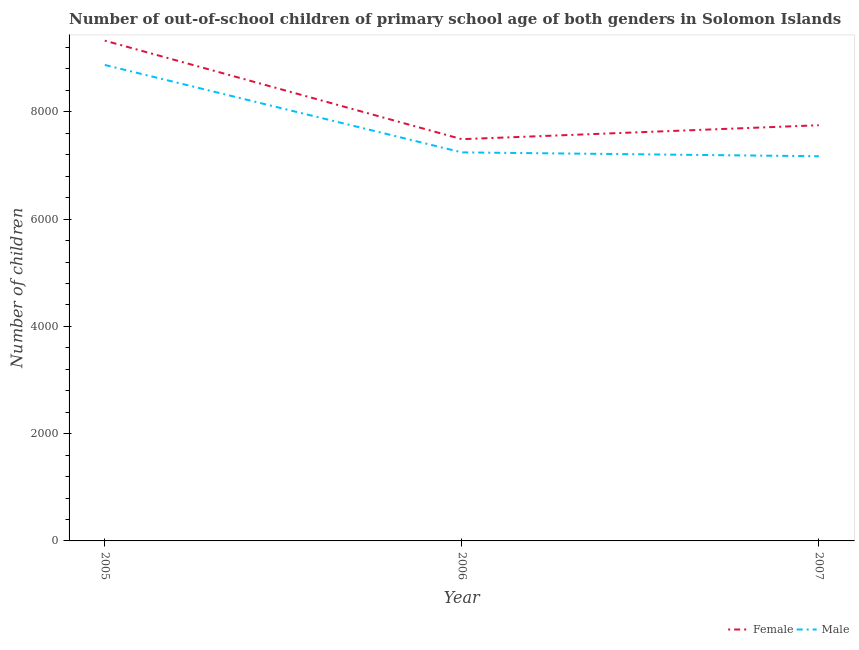Does the line corresponding to number of male out-of-school students intersect with the line corresponding to number of female out-of-school students?
Make the answer very short. No. What is the number of male out-of-school students in 2005?
Make the answer very short. 8874. Across all years, what is the maximum number of male out-of-school students?
Your answer should be very brief. 8874. Across all years, what is the minimum number of female out-of-school students?
Ensure brevity in your answer.  7490. What is the total number of male out-of-school students in the graph?
Provide a succinct answer. 2.33e+04. What is the difference between the number of male out-of-school students in 2006 and that in 2007?
Your answer should be compact. 72. What is the difference between the number of male out-of-school students in 2006 and the number of female out-of-school students in 2005?
Offer a very short reply. -2083. What is the average number of female out-of-school students per year?
Your answer should be compact. 8189. In the year 2006, what is the difference between the number of female out-of-school students and number of male out-of-school students?
Your answer should be very brief. 246. What is the ratio of the number of female out-of-school students in 2006 to that in 2007?
Make the answer very short. 0.97. Is the number of male out-of-school students in 2006 less than that in 2007?
Offer a very short reply. No. What is the difference between the highest and the second highest number of female out-of-school students?
Ensure brevity in your answer.  1577. What is the difference between the highest and the lowest number of female out-of-school students?
Provide a succinct answer. 1837. In how many years, is the number of female out-of-school students greater than the average number of female out-of-school students taken over all years?
Your response must be concise. 1. Is the sum of the number of female out-of-school students in 2006 and 2007 greater than the maximum number of male out-of-school students across all years?
Your response must be concise. Yes. Is the number of male out-of-school students strictly less than the number of female out-of-school students over the years?
Keep it short and to the point. Yes. How many lines are there?
Your answer should be compact. 2. What is the difference between two consecutive major ticks on the Y-axis?
Offer a terse response. 2000. Does the graph contain grids?
Make the answer very short. No. How many legend labels are there?
Offer a terse response. 2. How are the legend labels stacked?
Your answer should be compact. Horizontal. What is the title of the graph?
Your answer should be very brief. Number of out-of-school children of primary school age of both genders in Solomon Islands. What is the label or title of the Y-axis?
Make the answer very short. Number of children. What is the Number of children in Female in 2005?
Your response must be concise. 9327. What is the Number of children of Male in 2005?
Make the answer very short. 8874. What is the Number of children in Female in 2006?
Make the answer very short. 7490. What is the Number of children of Male in 2006?
Offer a very short reply. 7244. What is the Number of children in Female in 2007?
Provide a short and direct response. 7750. What is the Number of children in Male in 2007?
Your response must be concise. 7172. Across all years, what is the maximum Number of children in Female?
Ensure brevity in your answer.  9327. Across all years, what is the maximum Number of children in Male?
Make the answer very short. 8874. Across all years, what is the minimum Number of children of Female?
Provide a short and direct response. 7490. Across all years, what is the minimum Number of children of Male?
Keep it short and to the point. 7172. What is the total Number of children of Female in the graph?
Offer a terse response. 2.46e+04. What is the total Number of children of Male in the graph?
Keep it short and to the point. 2.33e+04. What is the difference between the Number of children of Female in 2005 and that in 2006?
Keep it short and to the point. 1837. What is the difference between the Number of children in Male in 2005 and that in 2006?
Keep it short and to the point. 1630. What is the difference between the Number of children in Female in 2005 and that in 2007?
Your answer should be very brief. 1577. What is the difference between the Number of children in Male in 2005 and that in 2007?
Offer a terse response. 1702. What is the difference between the Number of children of Female in 2006 and that in 2007?
Ensure brevity in your answer.  -260. What is the difference between the Number of children of Male in 2006 and that in 2007?
Offer a terse response. 72. What is the difference between the Number of children of Female in 2005 and the Number of children of Male in 2006?
Your response must be concise. 2083. What is the difference between the Number of children of Female in 2005 and the Number of children of Male in 2007?
Keep it short and to the point. 2155. What is the difference between the Number of children of Female in 2006 and the Number of children of Male in 2007?
Your answer should be compact. 318. What is the average Number of children in Female per year?
Your response must be concise. 8189. What is the average Number of children in Male per year?
Your answer should be compact. 7763.33. In the year 2005, what is the difference between the Number of children in Female and Number of children in Male?
Make the answer very short. 453. In the year 2006, what is the difference between the Number of children of Female and Number of children of Male?
Offer a terse response. 246. In the year 2007, what is the difference between the Number of children in Female and Number of children in Male?
Keep it short and to the point. 578. What is the ratio of the Number of children of Female in 2005 to that in 2006?
Give a very brief answer. 1.25. What is the ratio of the Number of children of Male in 2005 to that in 2006?
Your response must be concise. 1.23. What is the ratio of the Number of children in Female in 2005 to that in 2007?
Provide a short and direct response. 1.2. What is the ratio of the Number of children in Male in 2005 to that in 2007?
Your answer should be compact. 1.24. What is the ratio of the Number of children in Female in 2006 to that in 2007?
Offer a terse response. 0.97. What is the ratio of the Number of children in Male in 2006 to that in 2007?
Offer a terse response. 1.01. What is the difference between the highest and the second highest Number of children in Female?
Offer a very short reply. 1577. What is the difference between the highest and the second highest Number of children in Male?
Make the answer very short. 1630. What is the difference between the highest and the lowest Number of children in Female?
Keep it short and to the point. 1837. What is the difference between the highest and the lowest Number of children in Male?
Make the answer very short. 1702. 